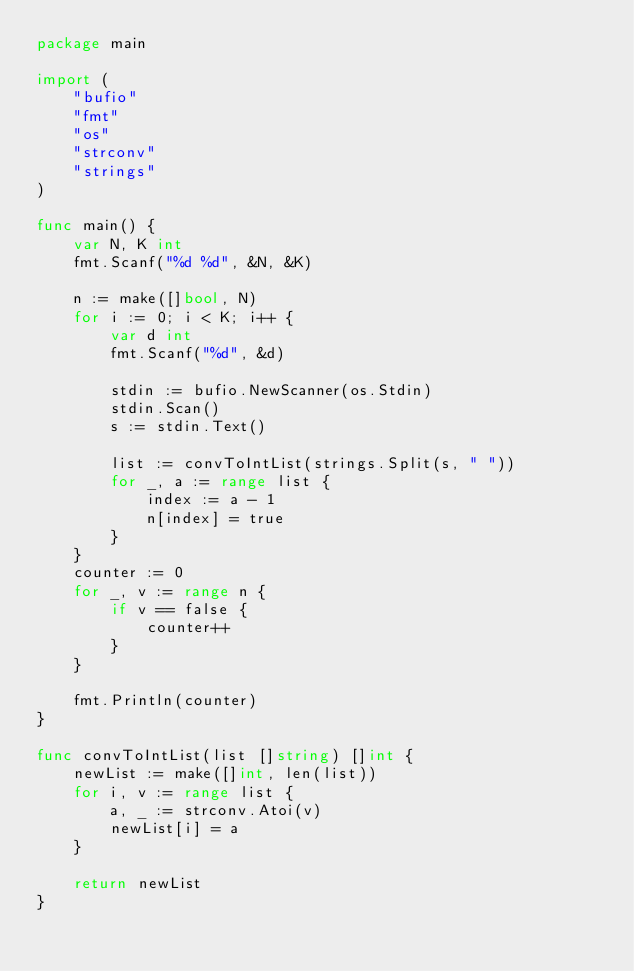Convert code to text. <code><loc_0><loc_0><loc_500><loc_500><_Go_>package main

import (
	"bufio"
	"fmt"
	"os"
	"strconv"
	"strings"
)

func main() {
	var N, K int
	fmt.Scanf("%d %d", &N, &K)

	n := make([]bool, N)
	for i := 0; i < K; i++ {
		var d int
		fmt.Scanf("%d", &d)

		stdin := bufio.NewScanner(os.Stdin)
		stdin.Scan()
		s := stdin.Text()

		list := convToIntList(strings.Split(s, " "))
		for _, a := range list {
			index := a - 1
			n[index] = true
		}
	}
	counter := 0
	for _, v := range n {
		if v == false {
			counter++
		}
	}

	fmt.Println(counter)
}

func convToIntList(list []string) []int {
	newList := make([]int, len(list))
	for i, v := range list {
		a, _ := strconv.Atoi(v)
		newList[i] = a
	}

	return newList
}
</code> 